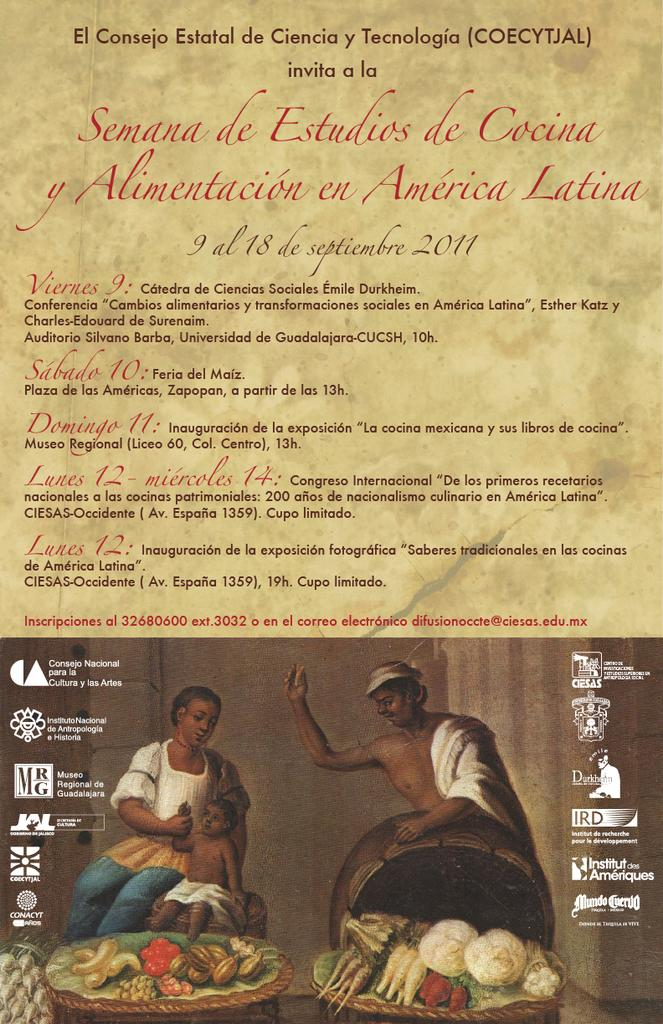What type of visual representation is the image? The image is a poster. What can be seen in the paintings on the poster? There are paintings of persons on the poster. What else is depicted in the poster besides the paintings? There are items on a table depicted in the poster. Is there any text present on the poster? Yes, there is text on the poster. How does the poster affect the boats in the image? There are no boats present in the image, so the poster cannot affect them. 